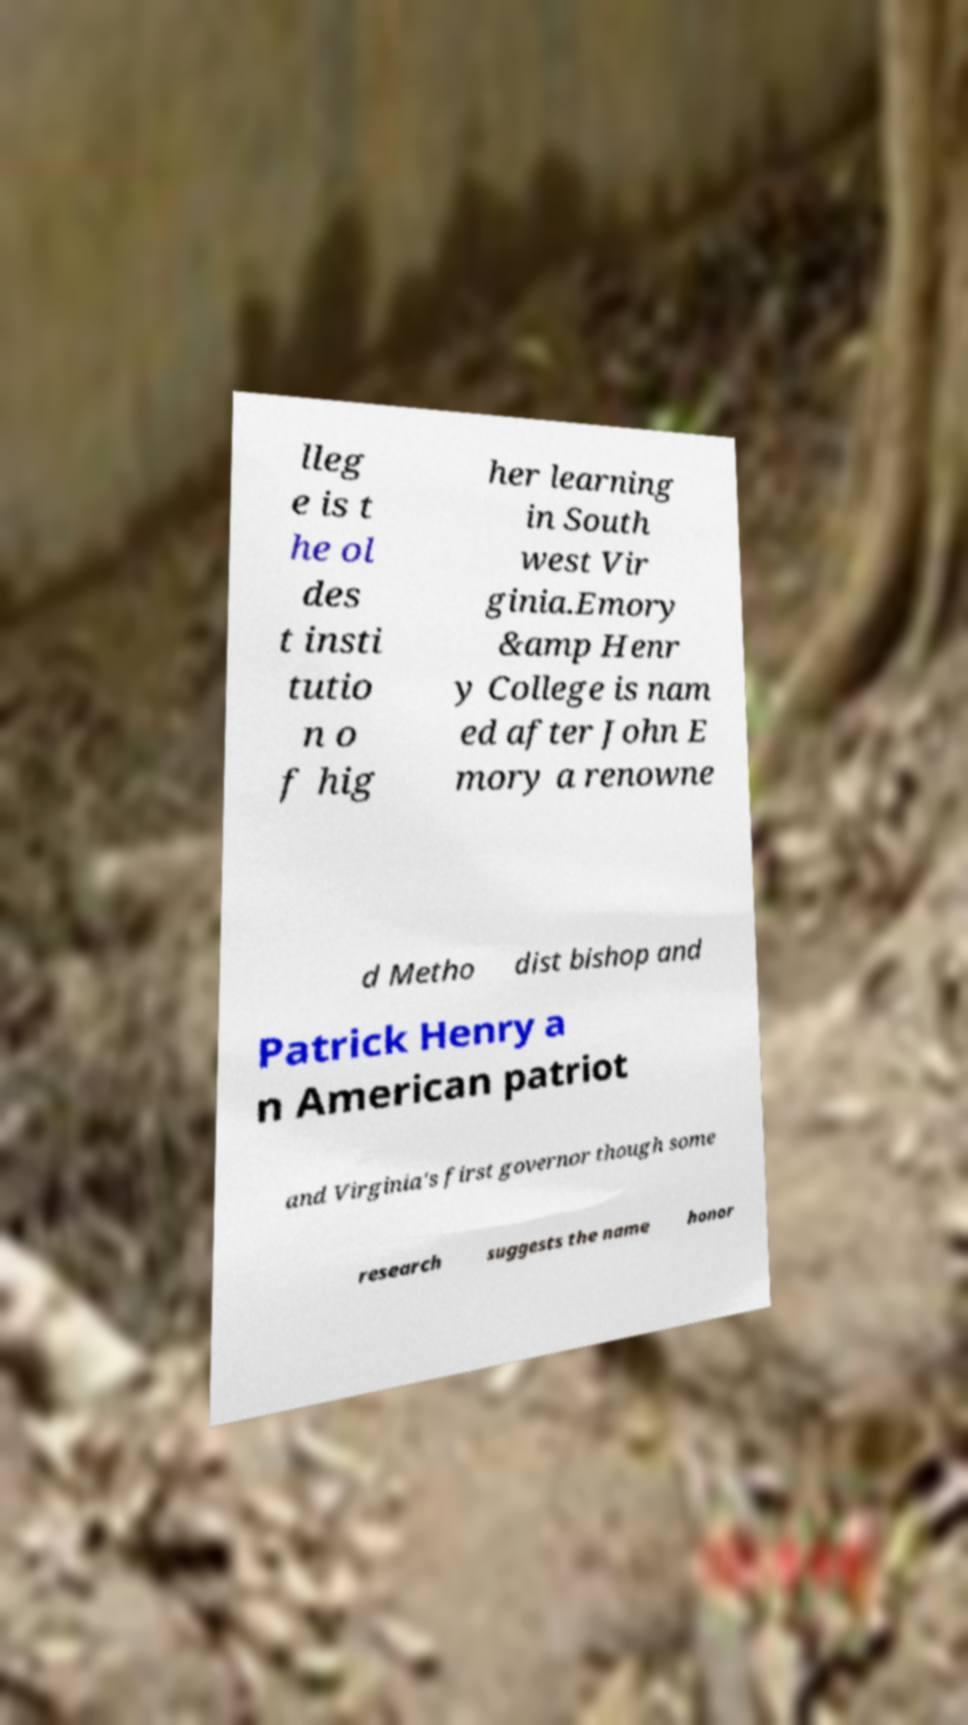Can you read and provide the text displayed in the image?This photo seems to have some interesting text. Can you extract and type it out for me? lleg e is t he ol des t insti tutio n o f hig her learning in South west Vir ginia.Emory &amp Henr y College is nam ed after John E mory a renowne d Metho dist bishop and Patrick Henry a n American patriot and Virginia's first governor though some research suggests the name honor 